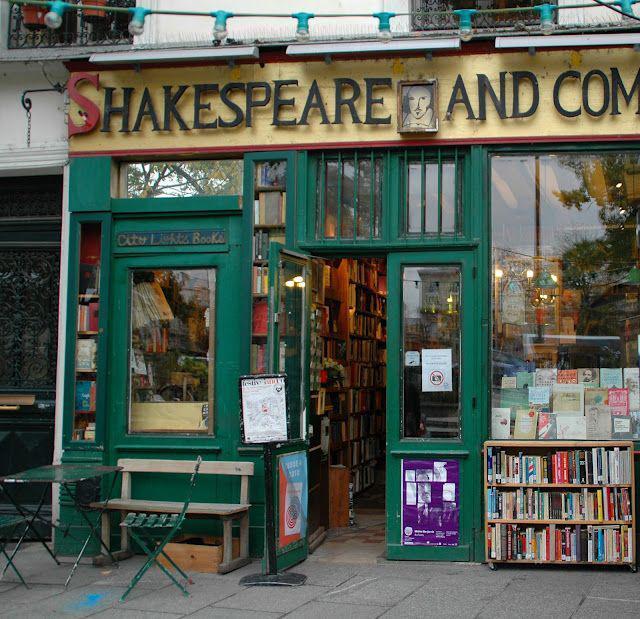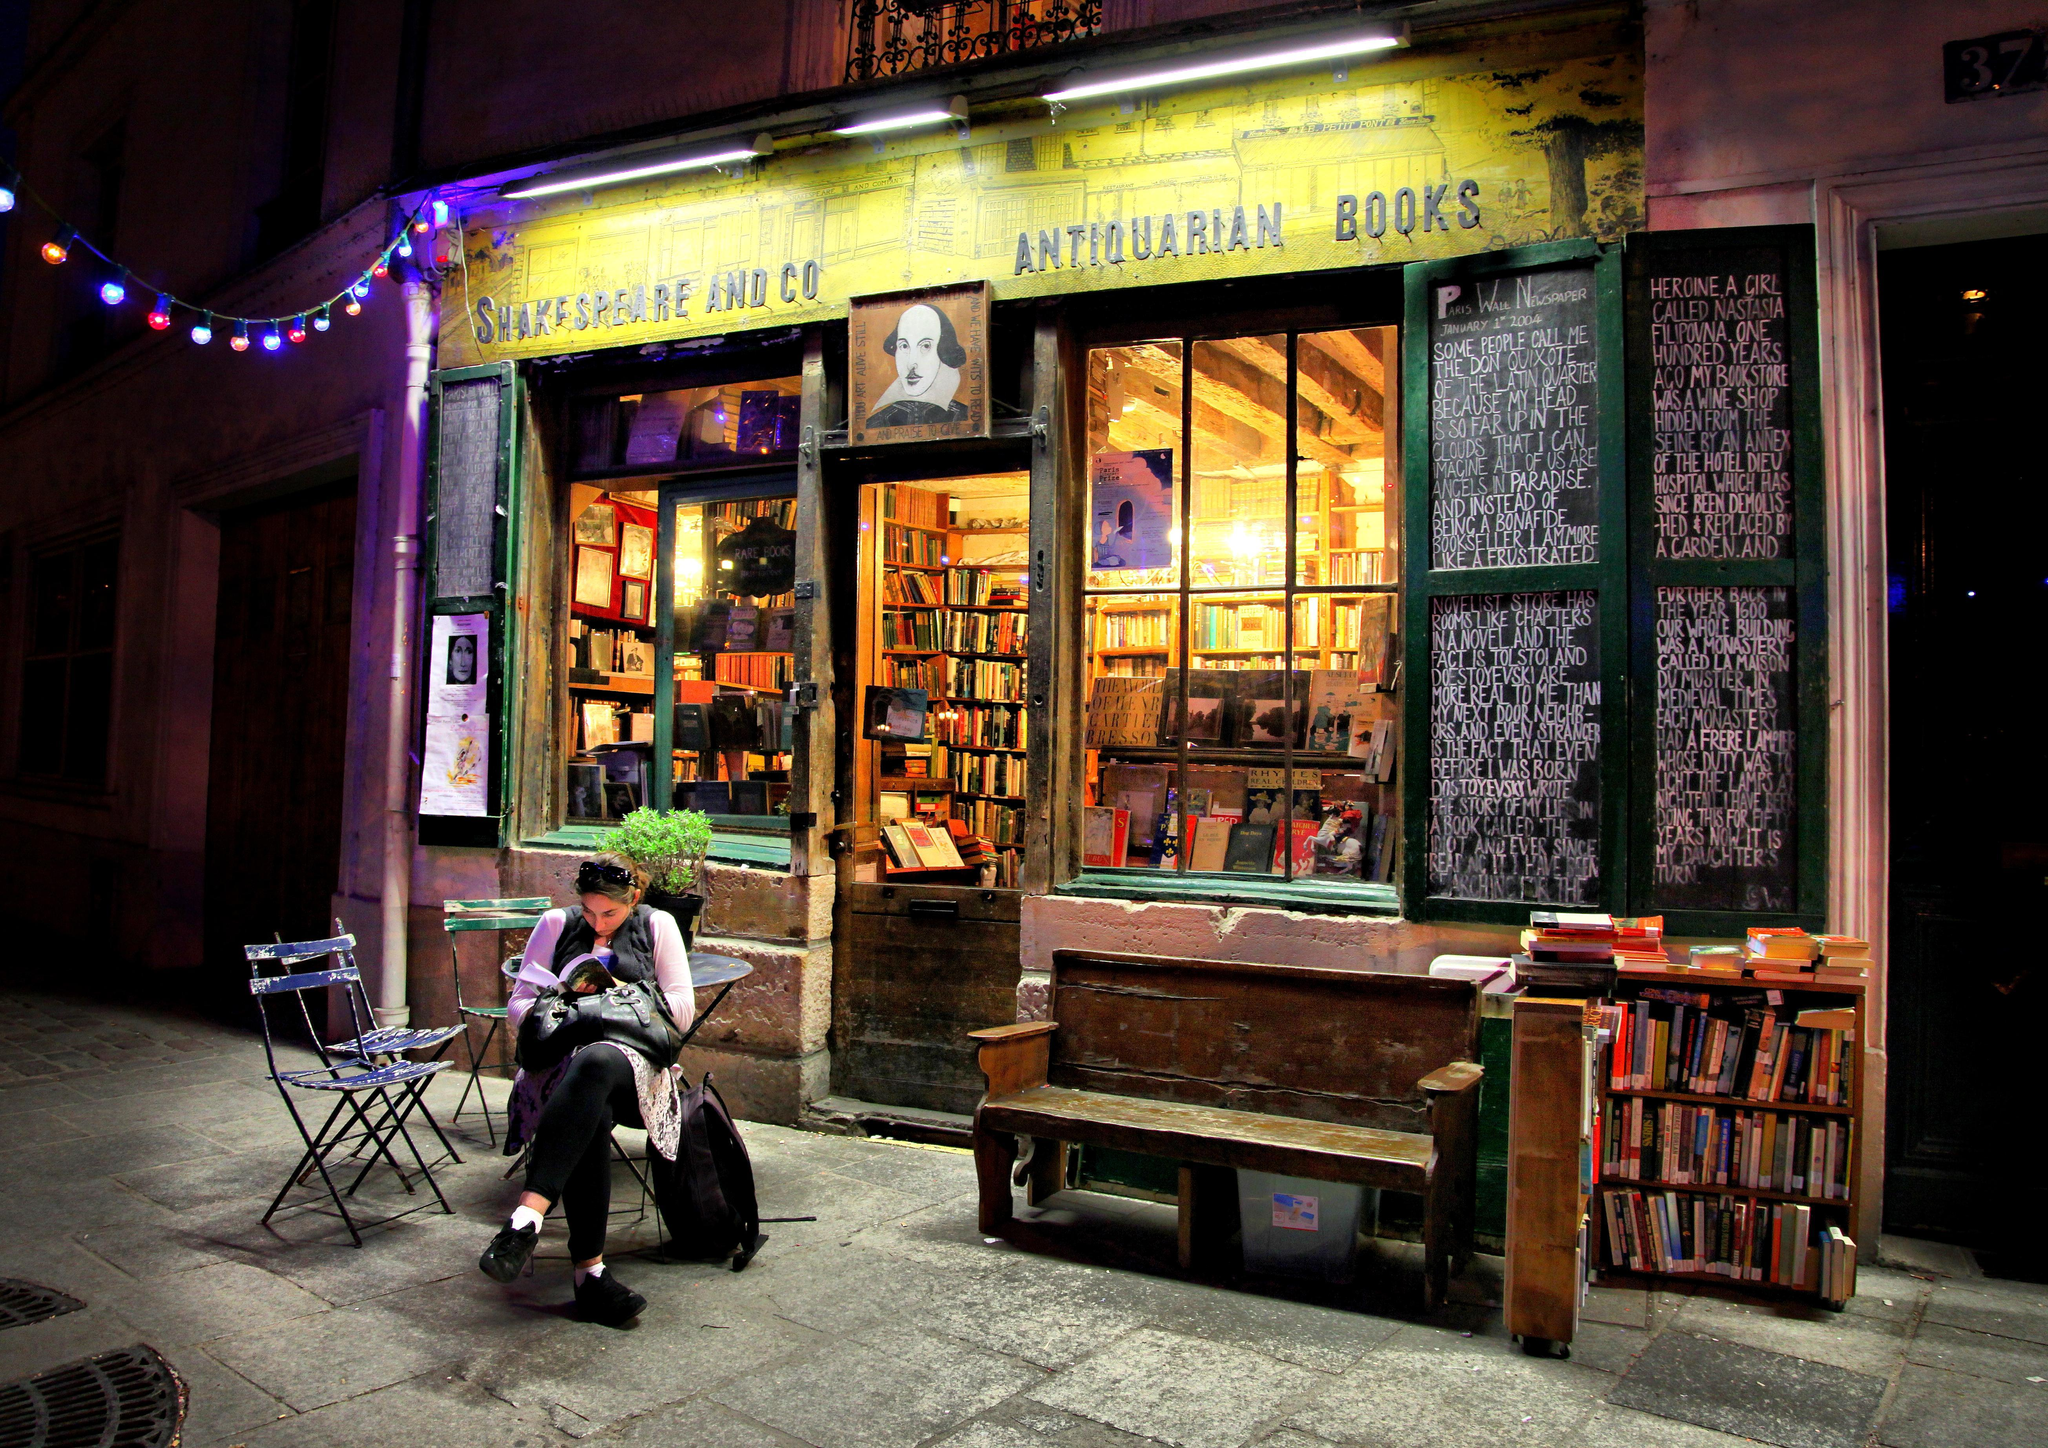The first image is the image on the left, the second image is the image on the right. Evaluate the accuracy of this statement regarding the images: "There are book shelves outside the store.". Is it true? Answer yes or no. Yes. The first image is the image on the left, the second image is the image on the right. Given the left and right images, does the statement "In at least one image there is a woman with dark hair reading a book off to the left side of the outside of a bookstore with yellow trim." hold true? Answer yes or no. Yes. 